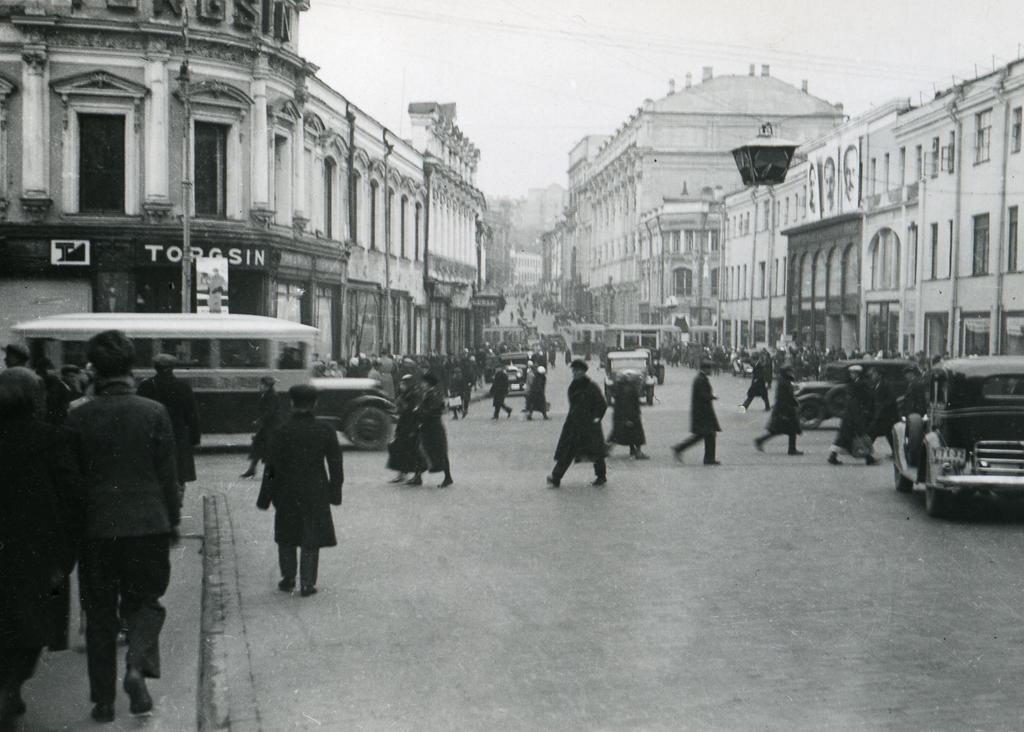Could you give a brief overview of what you see in this image? In this image there are buildings and we can see people. There are vehicles on the road. In the background there is sky. 